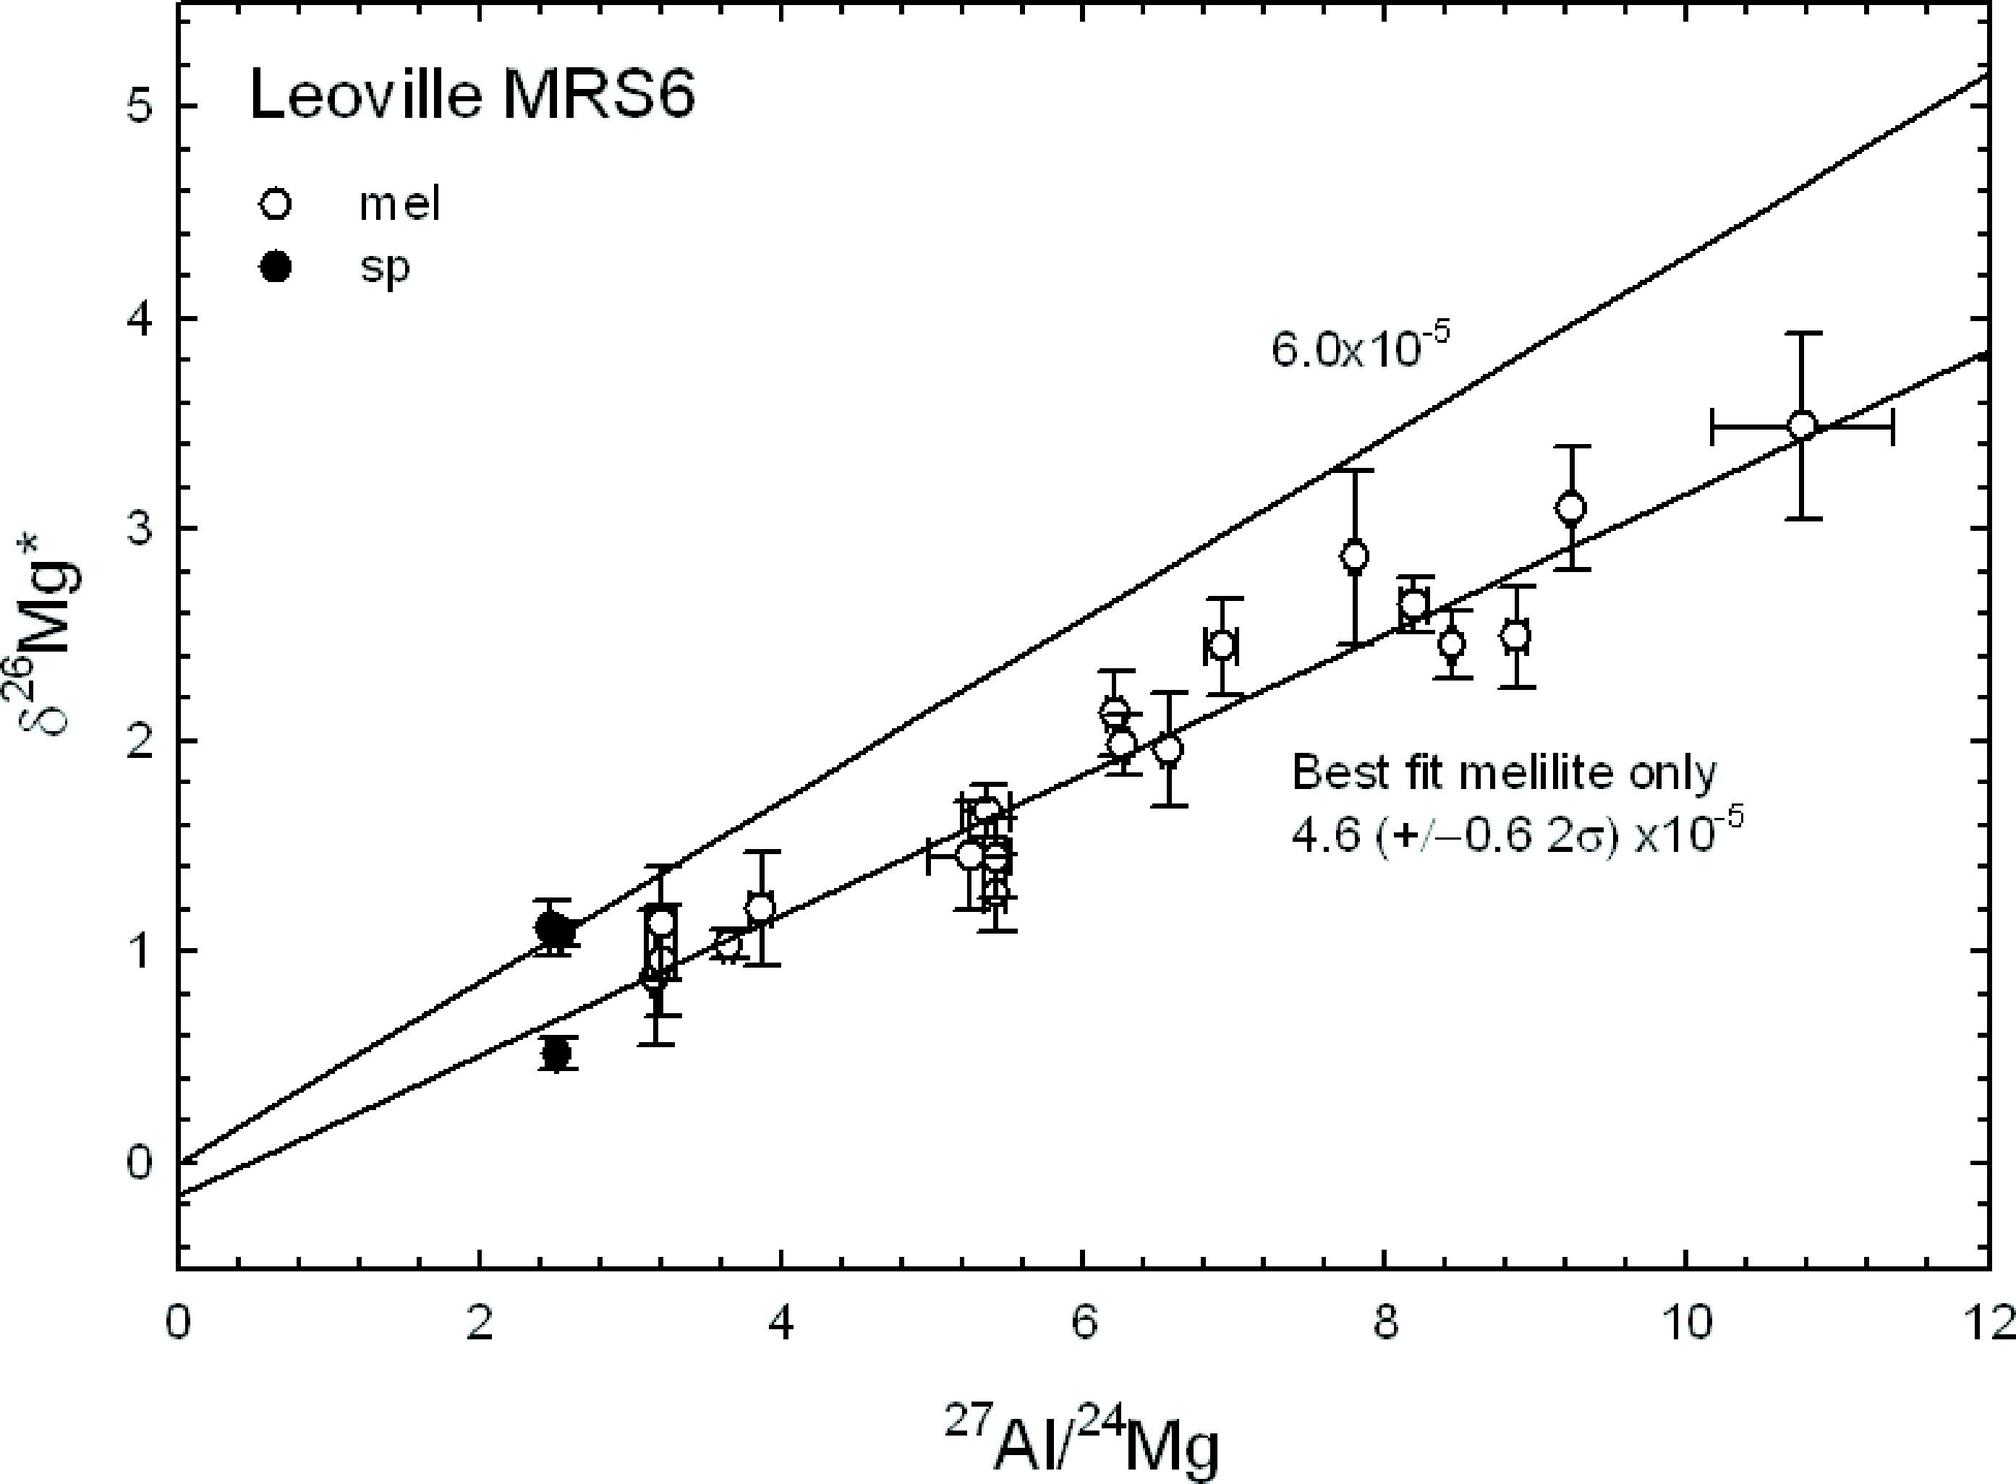What does the ratio of 27Al/24Mg tell us about geological processes? The ratio of 27Al to 24Mg, as explored in this graph, is often used in geochemical studies to understand the behavior of these elements in different geological environments. High ratios can indicate processes like crystallization in magmatic systems or differential partitioning during metamorphic reactions. Monitoring these ratios can provide insights into the conditions under which rocks form, including temperature and pressure conditions, and can help in reconstructing the thermal history of a rock or a geological event. 